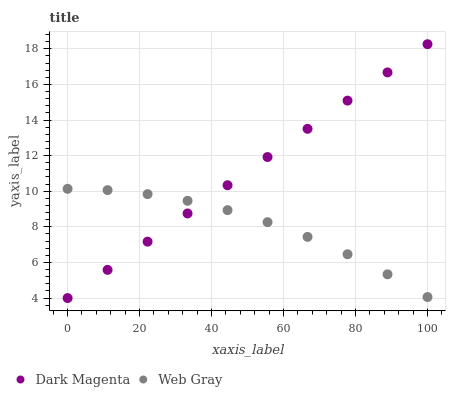Does Web Gray have the minimum area under the curve?
Answer yes or no. Yes. Does Dark Magenta have the maximum area under the curve?
Answer yes or no. Yes. Does Dark Magenta have the minimum area under the curve?
Answer yes or no. No. Is Dark Magenta the smoothest?
Answer yes or no. Yes. Is Web Gray the roughest?
Answer yes or no. Yes. Is Dark Magenta the roughest?
Answer yes or no. No. Does Dark Magenta have the lowest value?
Answer yes or no. Yes. Does Dark Magenta have the highest value?
Answer yes or no. Yes. Does Web Gray intersect Dark Magenta?
Answer yes or no. Yes. Is Web Gray less than Dark Magenta?
Answer yes or no. No. Is Web Gray greater than Dark Magenta?
Answer yes or no. No. 